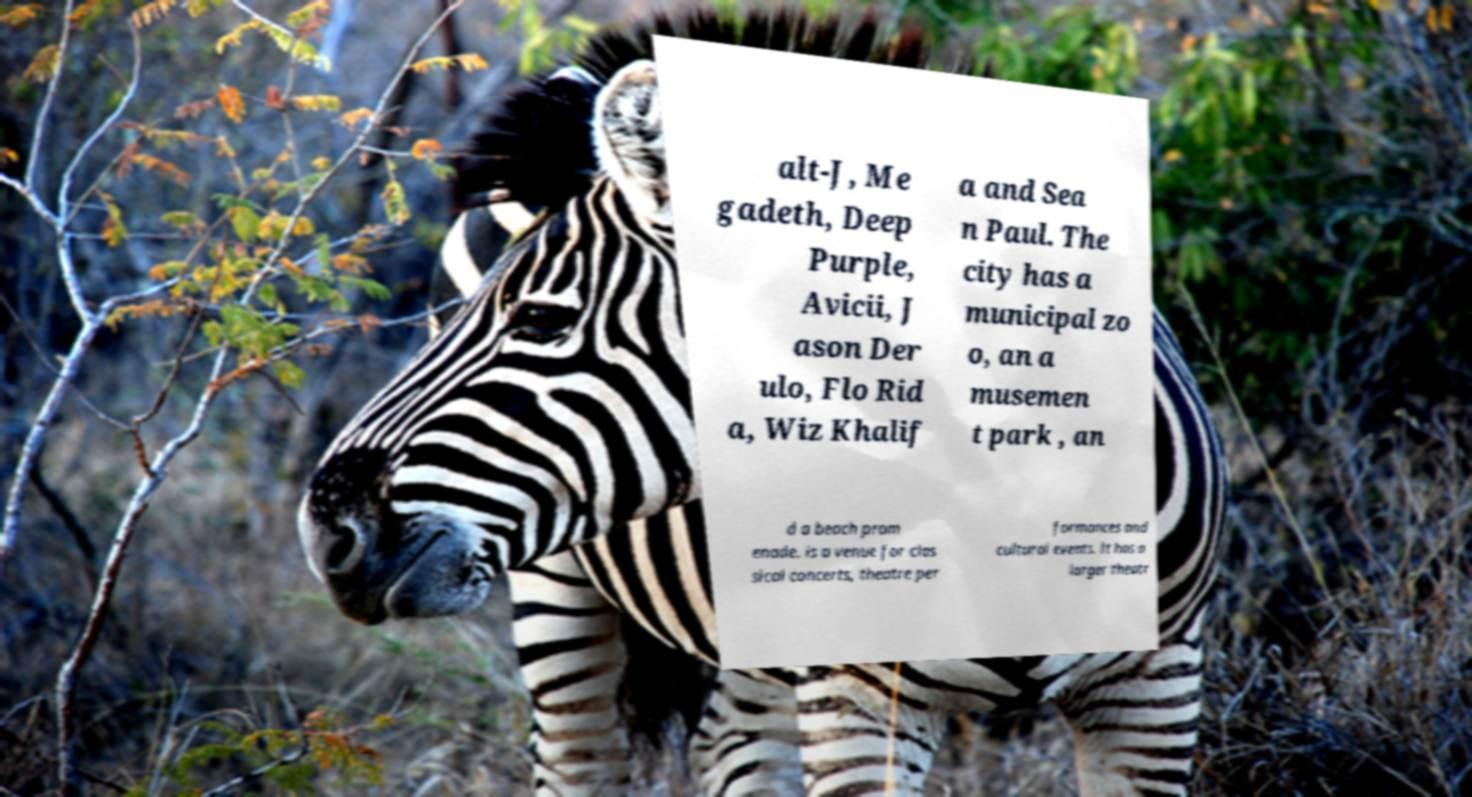Can you accurately transcribe the text from the provided image for me? alt-J, Me gadeth, Deep Purple, Avicii, J ason Der ulo, Flo Rid a, Wiz Khalif a and Sea n Paul. The city has a municipal zo o, an a musemen t park , an d a beach prom enade. is a venue for clas sical concerts, theatre per formances and cultural events. It has a larger theatr 